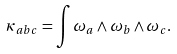<formula> <loc_0><loc_0><loc_500><loc_500>\kappa _ { a b c } = \int \omega _ { a } \wedge \omega _ { b } \wedge \omega _ { c } .</formula> 